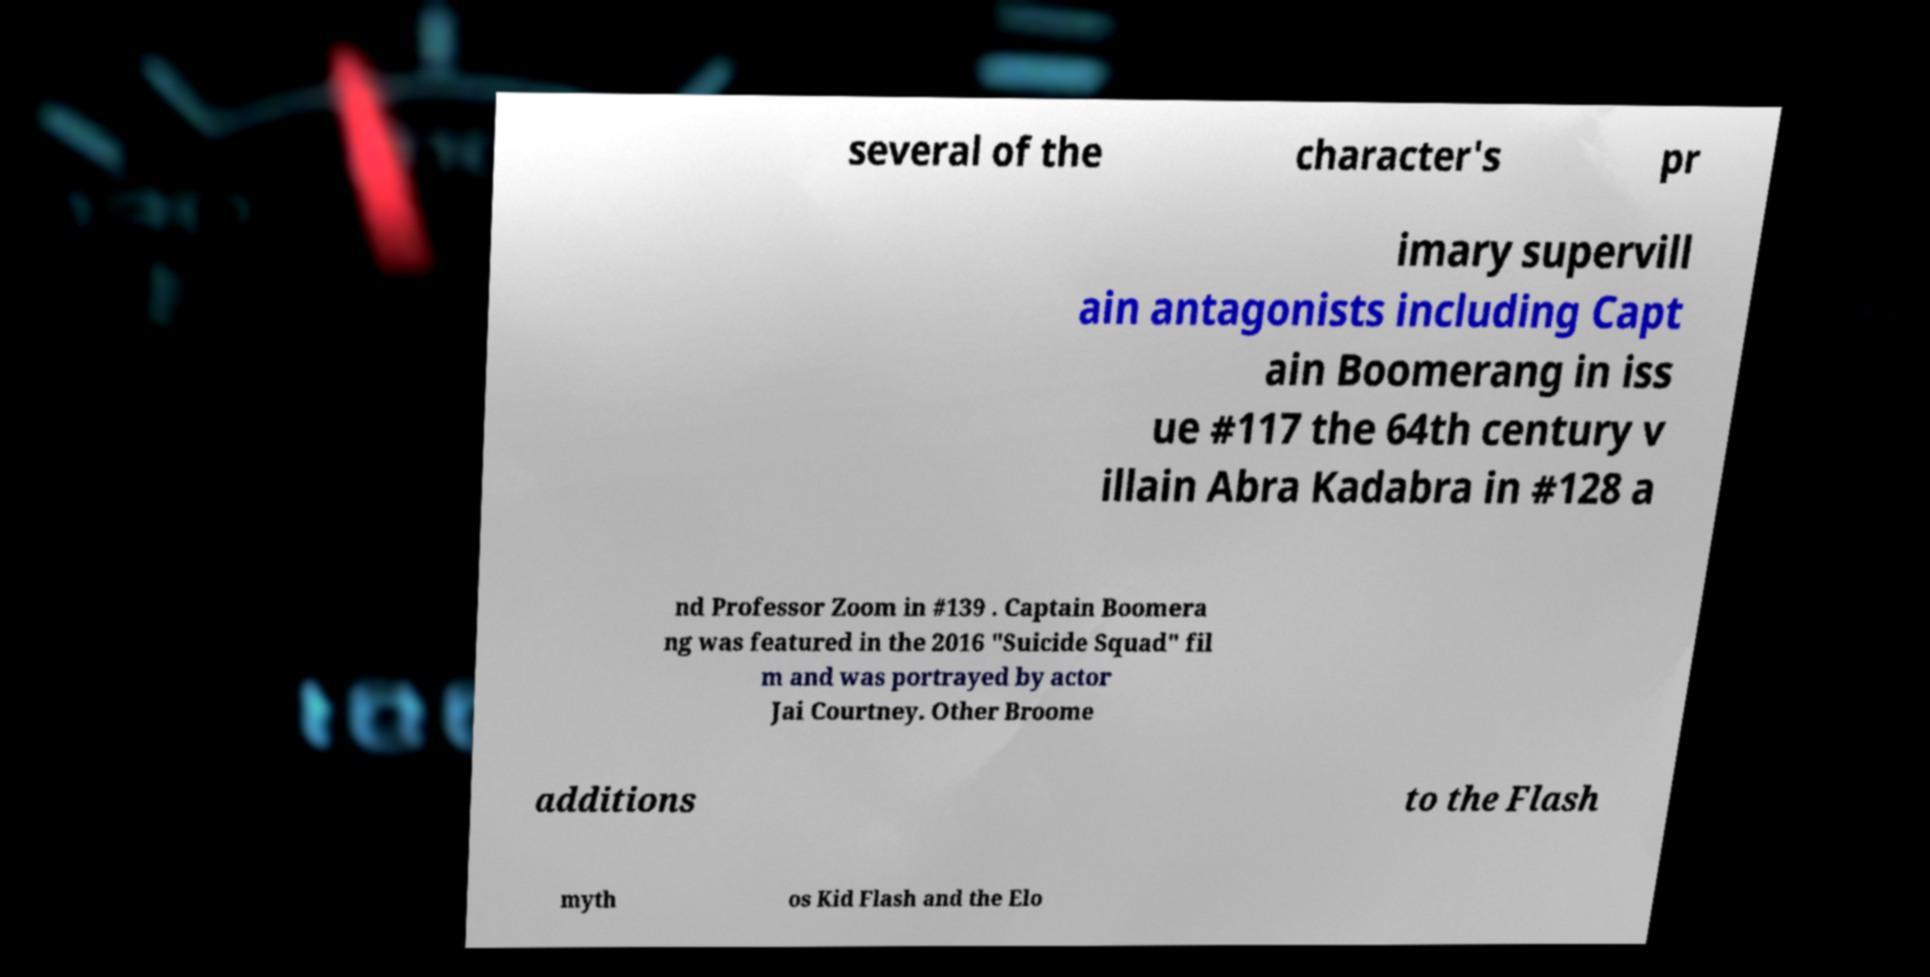Can you read and provide the text displayed in the image?This photo seems to have some interesting text. Can you extract and type it out for me? several of the character's pr imary supervill ain antagonists including Capt ain Boomerang in iss ue #117 the 64th century v illain Abra Kadabra in #128 a nd Professor Zoom in #139 . Captain Boomera ng was featured in the 2016 "Suicide Squad" fil m and was portrayed by actor Jai Courtney. Other Broome additions to the Flash myth os Kid Flash and the Elo 